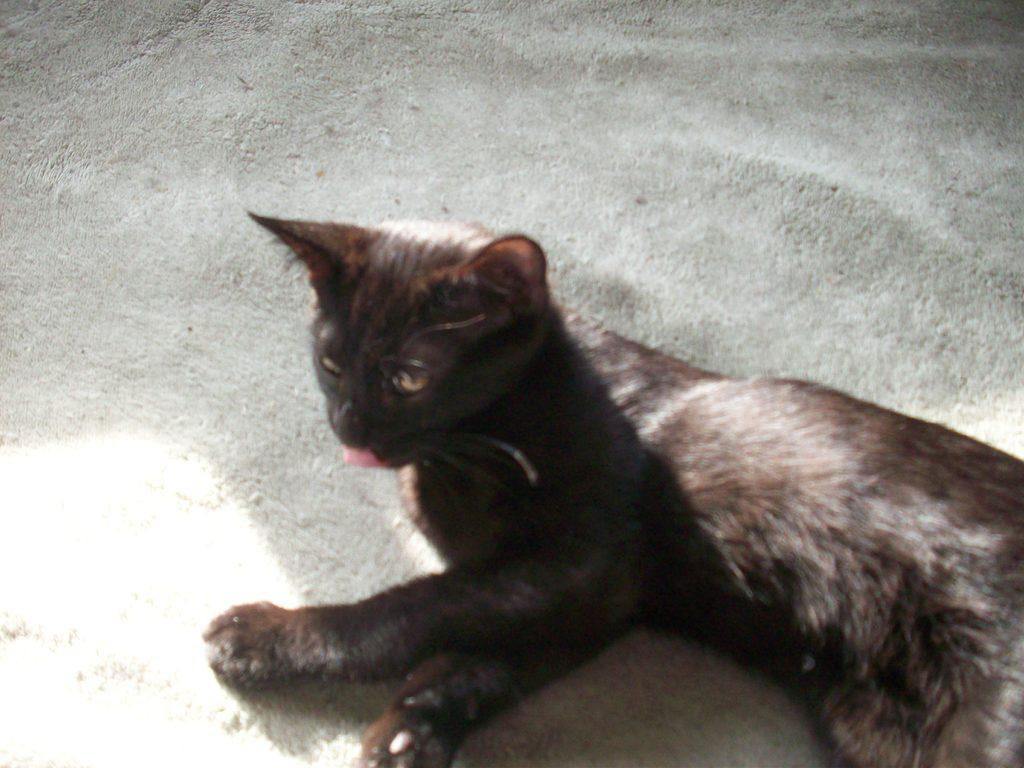What type of animal is in the image? There is a black cat in the image. What color is the background of the image? The background of the image is white in color. What word does the cat use to express its opinion about the approval process? Cats do not use words to express opinions, and there is no approval process depicted in the image. 